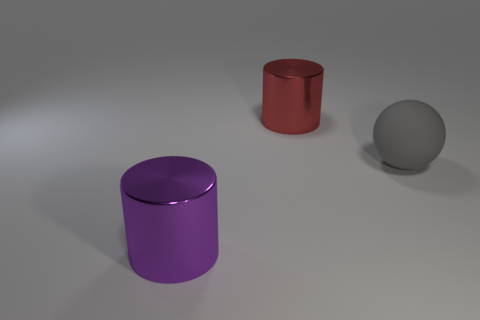Is the number of big objects less than the number of large red metallic objects? Upon reviewing the image, it appears that there is one large red metallic object and there are two big objects in total, one being the large red metallic cylinder and the other being a large purple metallic cylinder. Therefore, the number of big objects is not less than the number of large red metallic objects; they are equal in count. 